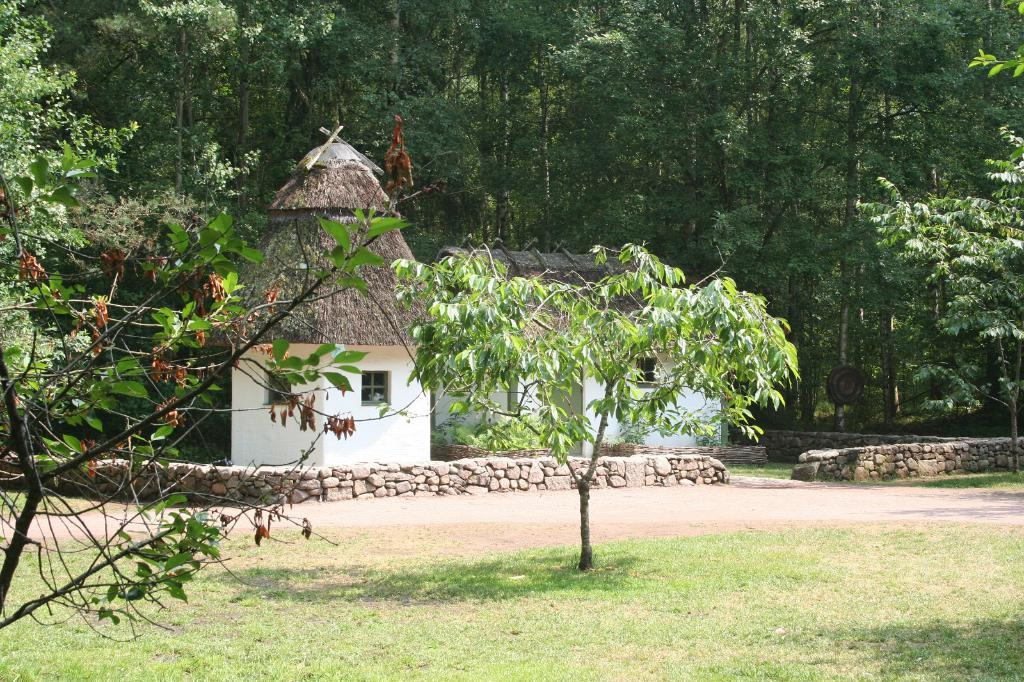What type of vegetation is present on the ground in the front of the image? There is grass on the ground in the front of the image. What can be seen on the left side of the image? There is a tree on the left side of the image. What is located in the center of the image? There is a plant in the center of the image. What structures are visible in the background of the image? There are huts in the background of the image. What else can be seen in the background of the image? There are trees in the background of the image. Can you see a badge on the tree in the image? There is no badge present on the tree in the image. Is there an airplane flying over the huts in the background of the image? There is no airplane visible in the image. What type of scale is used to measure the size of the plant in the center of the image? There is no scale present in the image to measure the size of the plant. 